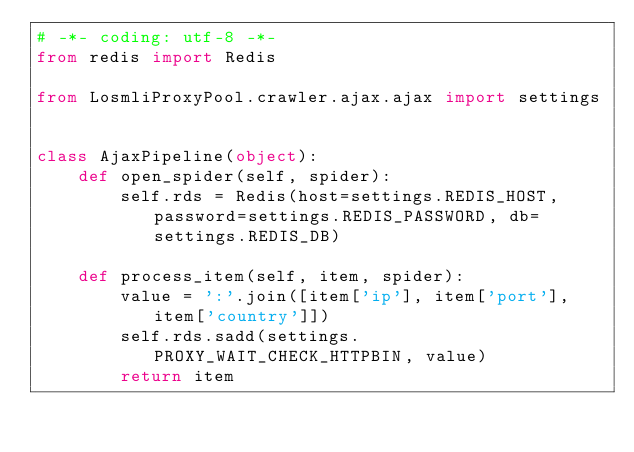<code> <loc_0><loc_0><loc_500><loc_500><_Python_># -*- coding: utf-8 -*-
from redis import Redis

from LosmliProxyPool.crawler.ajax.ajax import settings


class AjaxPipeline(object):
    def open_spider(self, spider):
        self.rds = Redis(host=settings.REDIS_HOST, password=settings.REDIS_PASSWORD, db=settings.REDIS_DB)

    def process_item(self, item, spider):
        value = ':'.join([item['ip'], item['port'], item['country']])
        self.rds.sadd(settings.PROXY_WAIT_CHECK_HTTPBIN, value)
        return item
</code> 